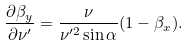<formula> <loc_0><loc_0><loc_500><loc_500>\frac { \partial \beta _ { y } } { \partial \nu ^ { \prime } } = \frac { \nu } { \nu ^ { \prime 2 } \sin { \alpha } } ( 1 - \beta _ { x } ) .</formula> 